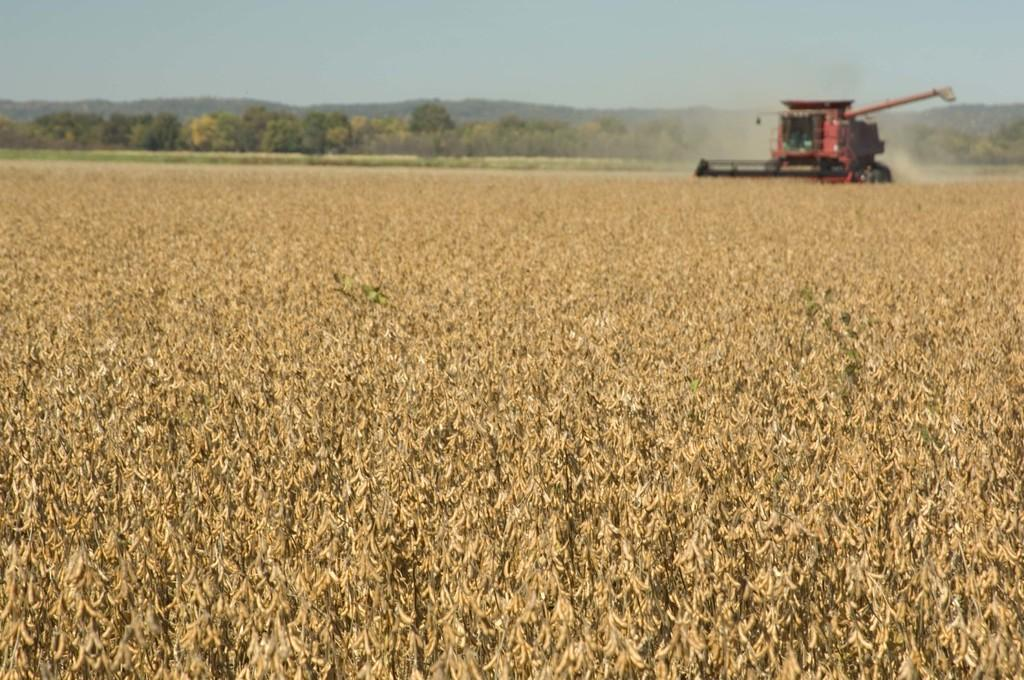What is the main setting of the image? The image depicts a field. What can be found in the field? There are plants in the field. What is visible in the background towards the right? There is a machine in the background towards the right. What else can be seen in the background? There are trees in the background. How would you describe the weather in the image? The sky is sunny in the image. What type of acoustics can be heard in the field during the show? There is no show or acoustics present in the image; it depicts a field with plants, a machine, and trees in the background. What flavor of pie is being served in the field? There is no pie present in the image; it depicts a field with plants, a machine, and trees in the background. 